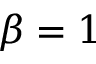<formula> <loc_0><loc_0><loc_500><loc_500>\beta = 1</formula> 